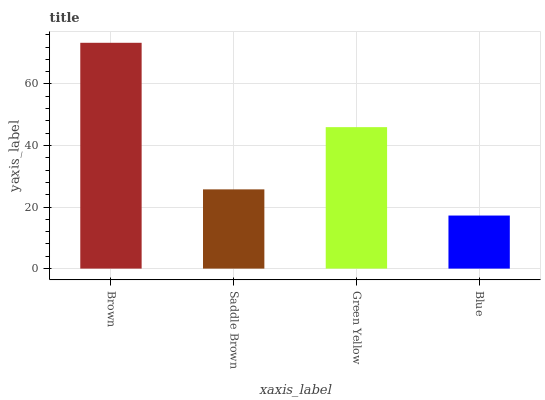Is Blue the minimum?
Answer yes or no. Yes. Is Brown the maximum?
Answer yes or no. Yes. Is Saddle Brown the minimum?
Answer yes or no. No. Is Saddle Brown the maximum?
Answer yes or no. No. Is Brown greater than Saddle Brown?
Answer yes or no. Yes. Is Saddle Brown less than Brown?
Answer yes or no. Yes. Is Saddle Brown greater than Brown?
Answer yes or no. No. Is Brown less than Saddle Brown?
Answer yes or no. No. Is Green Yellow the high median?
Answer yes or no. Yes. Is Saddle Brown the low median?
Answer yes or no. Yes. Is Blue the high median?
Answer yes or no. No. Is Green Yellow the low median?
Answer yes or no. No. 